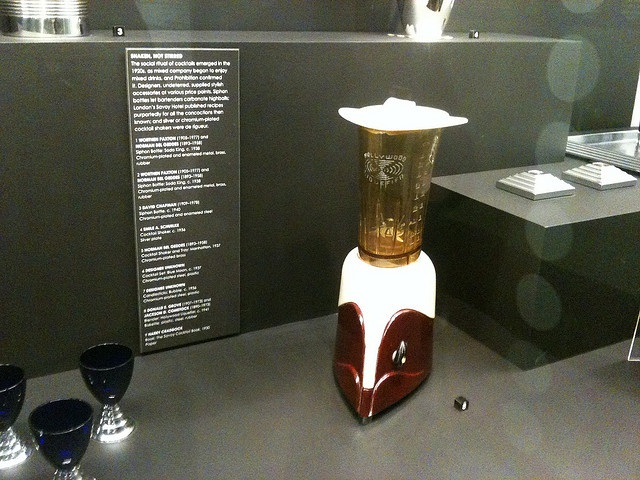Describe the objects in this image and their specific colors. I can see cup in darkgreen, olive, and black tones, wine glass in darkgreen, black, white, gray, and darkgray tones, and wine glass in darkgreen, black, white, gray, and darkgray tones in this image. 